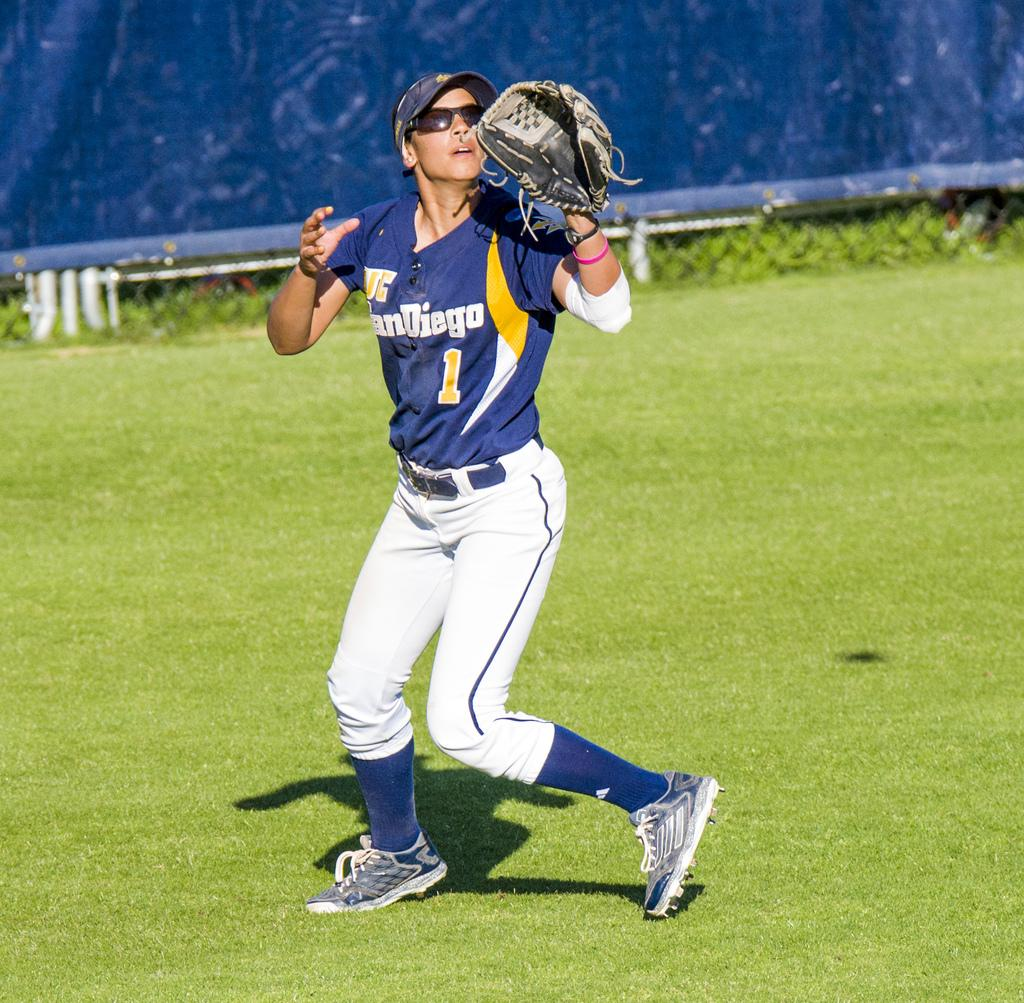<image>
Offer a succinct explanation of the picture presented. A woman wearing a San Diego jersey and a catcher's mitt looks upward. 